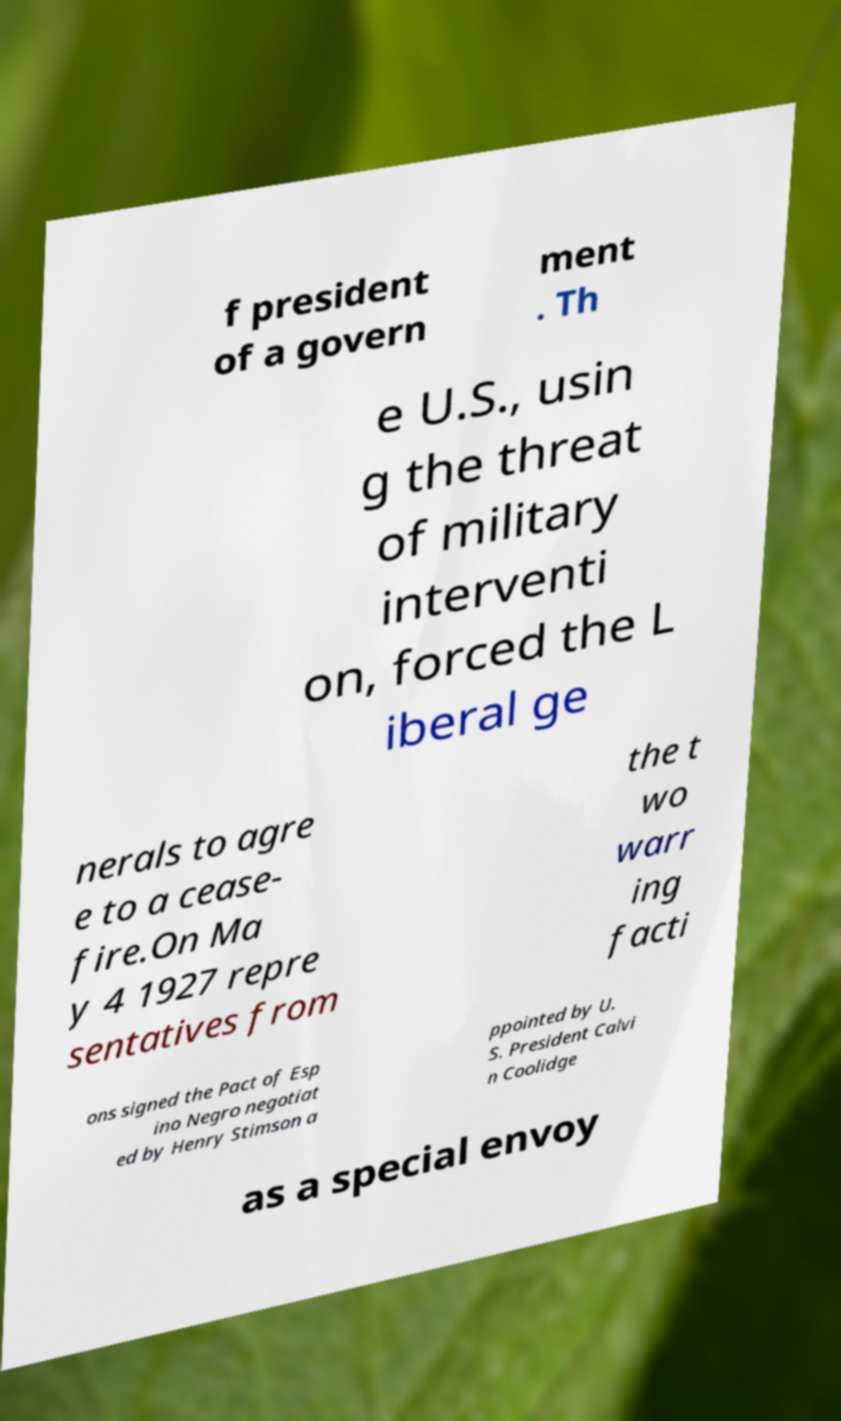Can you accurately transcribe the text from the provided image for me? f president of a govern ment . Th e U.S., usin g the threat of military interventi on, forced the L iberal ge nerals to agre e to a cease- fire.On Ma y 4 1927 repre sentatives from the t wo warr ing facti ons signed the Pact of Esp ino Negro negotiat ed by Henry Stimson a ppointed by U. S. President Calvi n Coolidge as a special envoy 